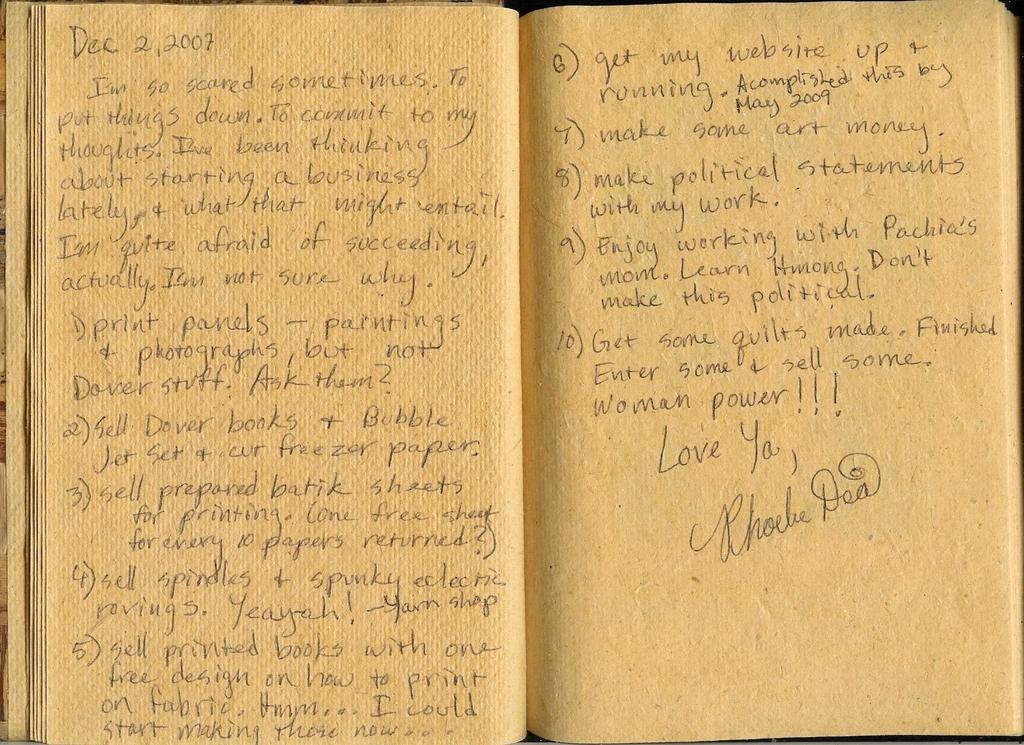Does it say "love ya" or "love you" at the end?
Provide a succinct answer. Love ya. 